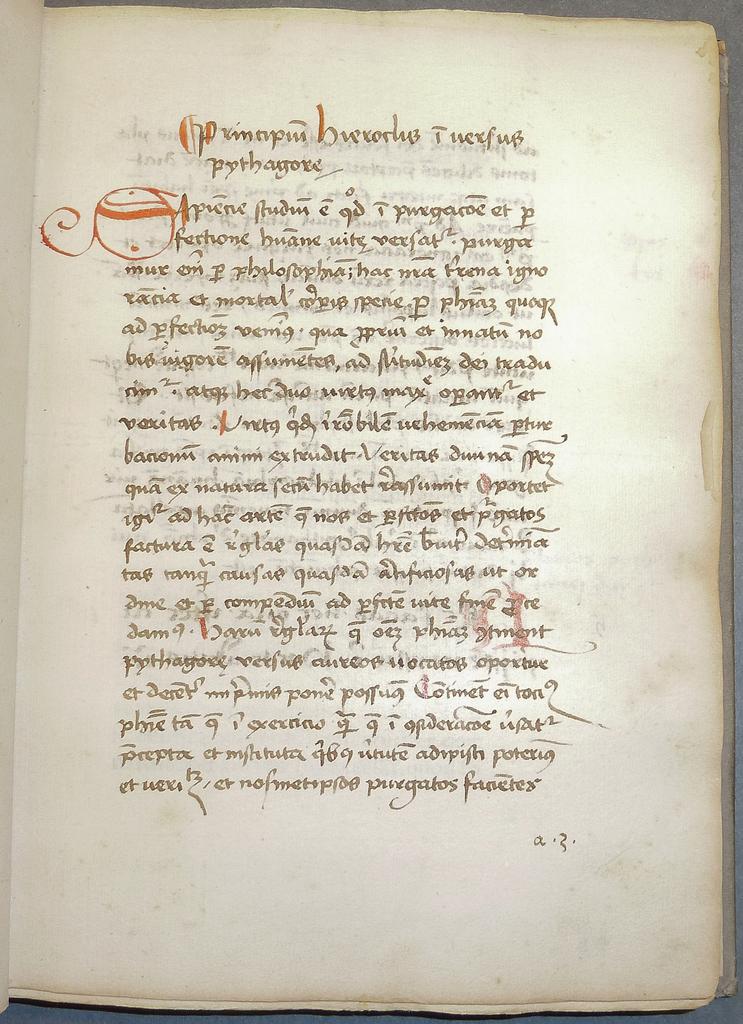Is this paper readable without assistance?
Give a very brief answer. No. All foreign language?
Keep it short and to the point. Yes. 